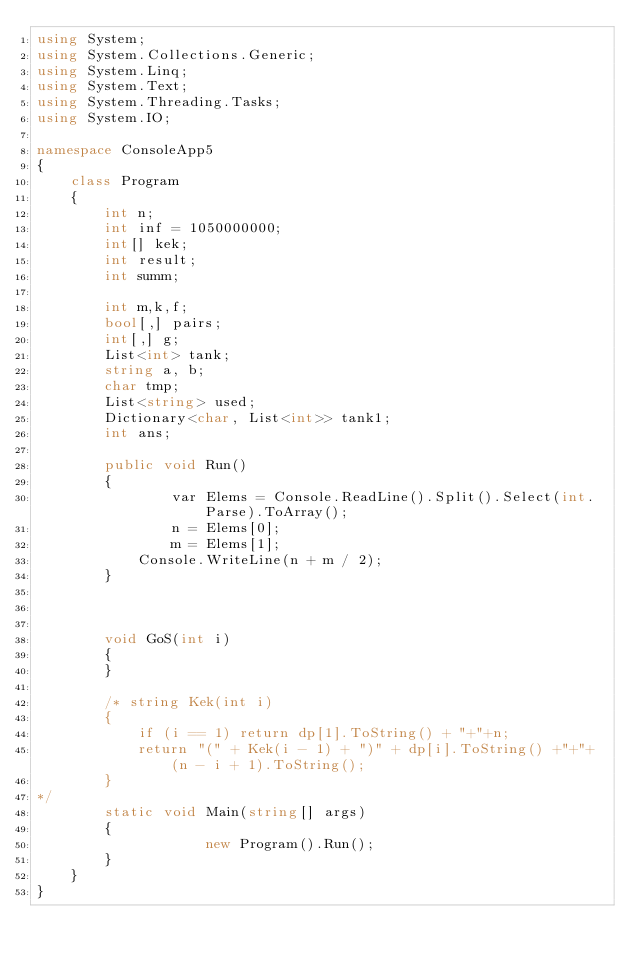<code> <loc_0><loc_0><loc_500><loc_500><_C#_>using System;
using System.Collections.Generic;
using System.Linq;
using System.Text;
using System.Threading.Tasks;
using System.IO;

namespace ConsoleApp5
{
    class Program
    {
        int n;
        int inf = 1050000000;
        int[] kek;
        int result;
        int summ;
       
        int m,k,f;
        bool[,] pairs;
        int[,] g;
        List<int> tank;
        string a, b;
        char tmp;
        List<string> used;
        Dictionary<char, List<int>> tank1;
        int ans;

        public void Run()
        {
                var Elems = Console.ReadLine().Split().Select(int.Parse).ToArray();
                n = Elems[0];
                m = Elems[1];
            Console.WriteLine(n + m / 2);
        }

        
       
        void GoS(int i)
        {
        }

        /* string Kek(int i)
        {
            if (i == 1) return dp[1].ToString() + "+"+n;
            return "(" + Kek(i - 1) + ")" + dp[i].ToString() +"+"+ (n - i + 1).ToString();
        }
*/
        static void Main(string[] args)
        {
                    new Program().Run();
        }
    }
}
</code> 